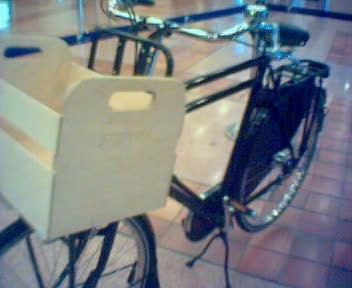Can you describe the surroundings where this bicycle is located? The bicycle is situated in an indoor setting with tiled flooring, likely a public or semi-public area. The tiles have a square pattern, and lighting in the area seems ambient and diffused, suggesting an interior space without direct sunlight. 